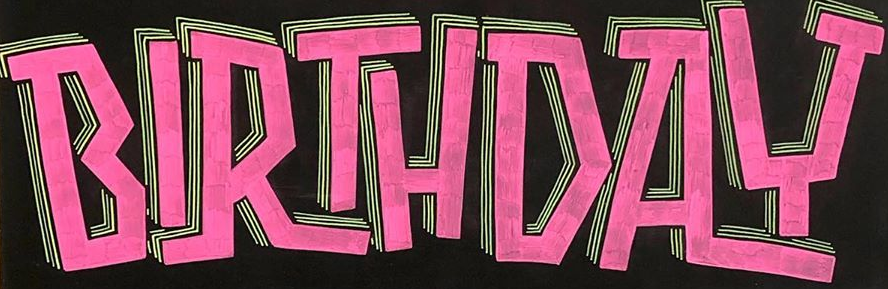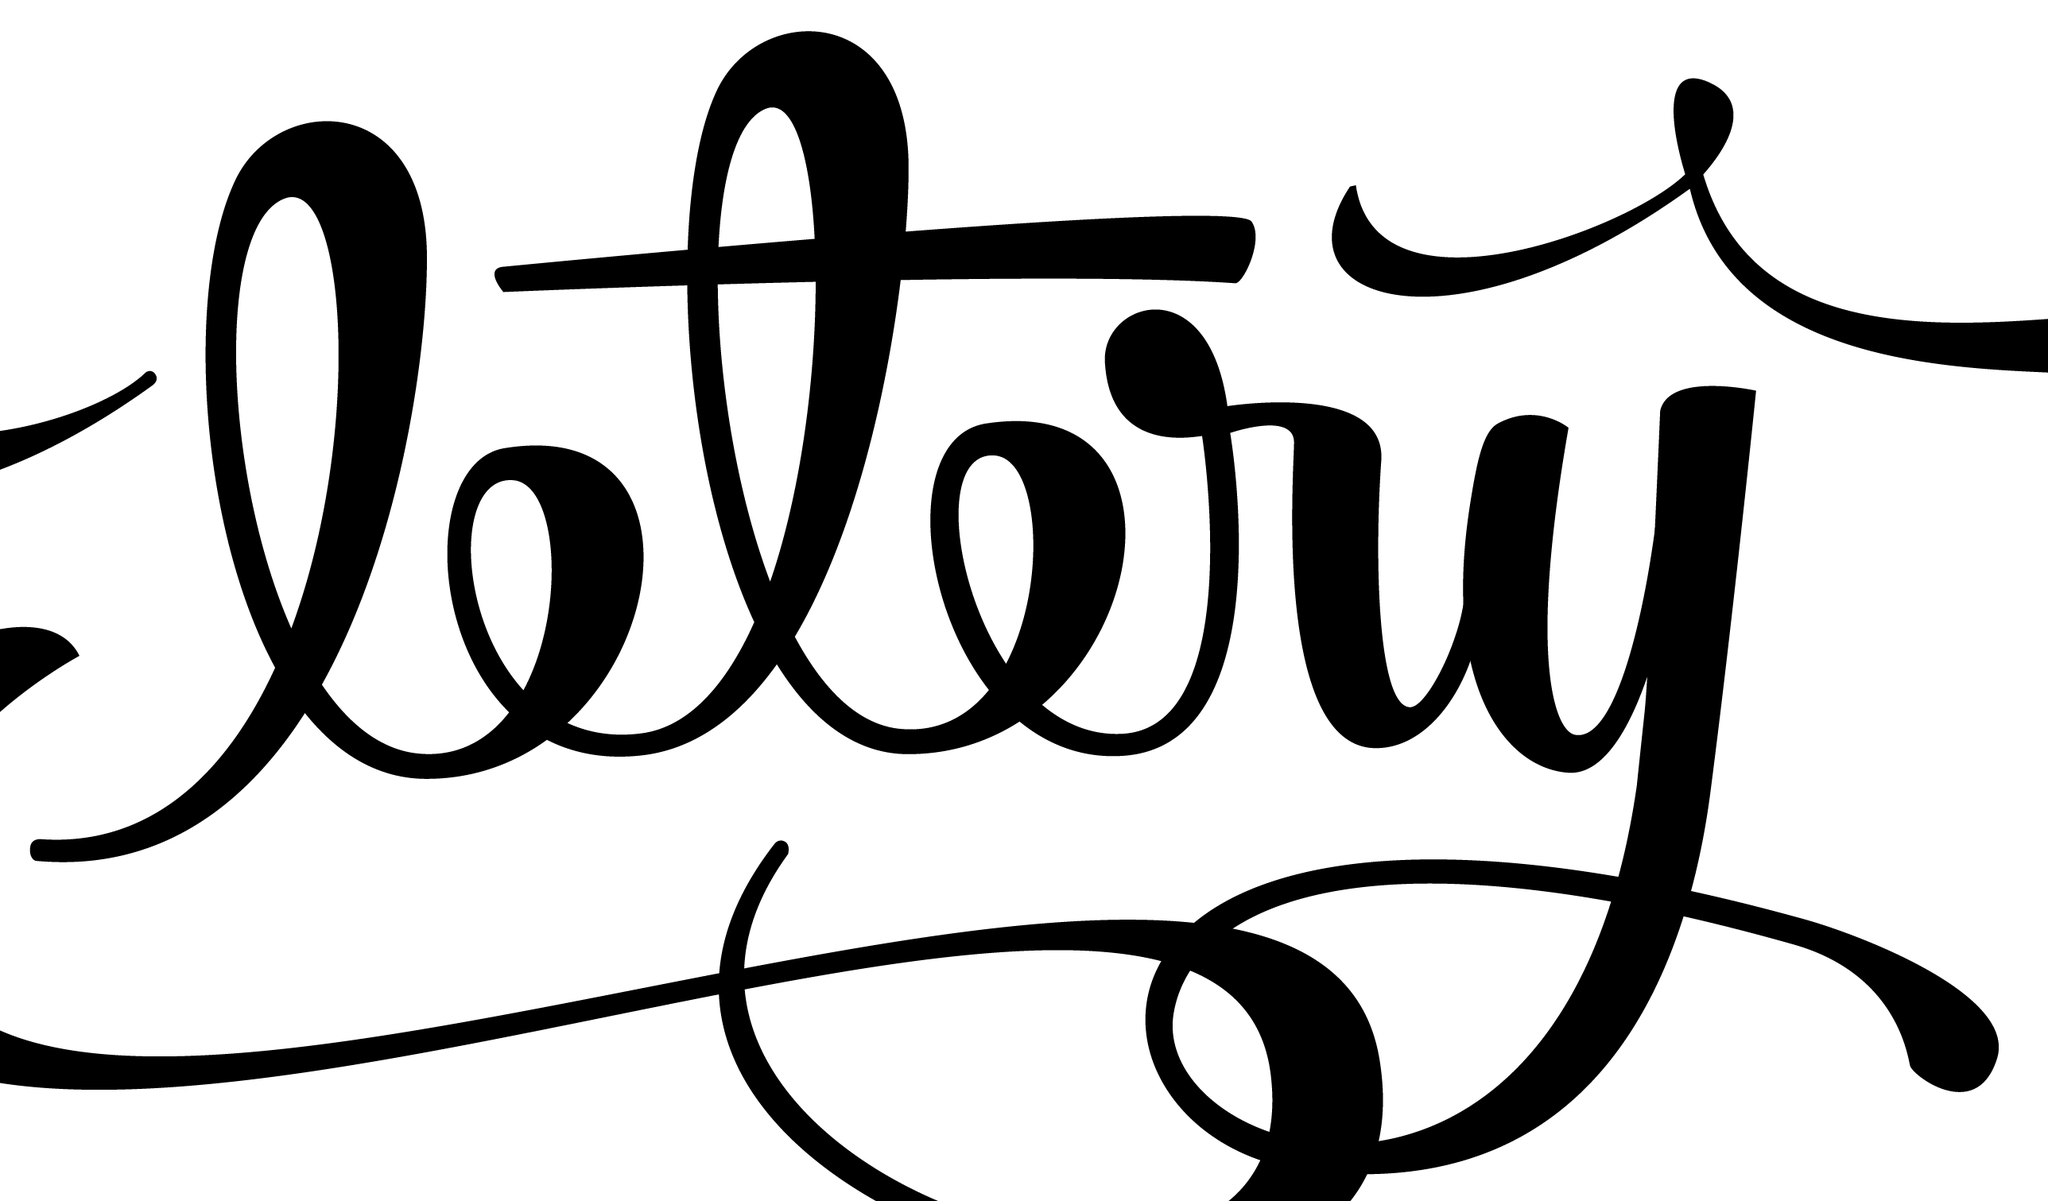Read the text from these images in sequence, separated by a semicolon. BIRTHDAY; ltry 